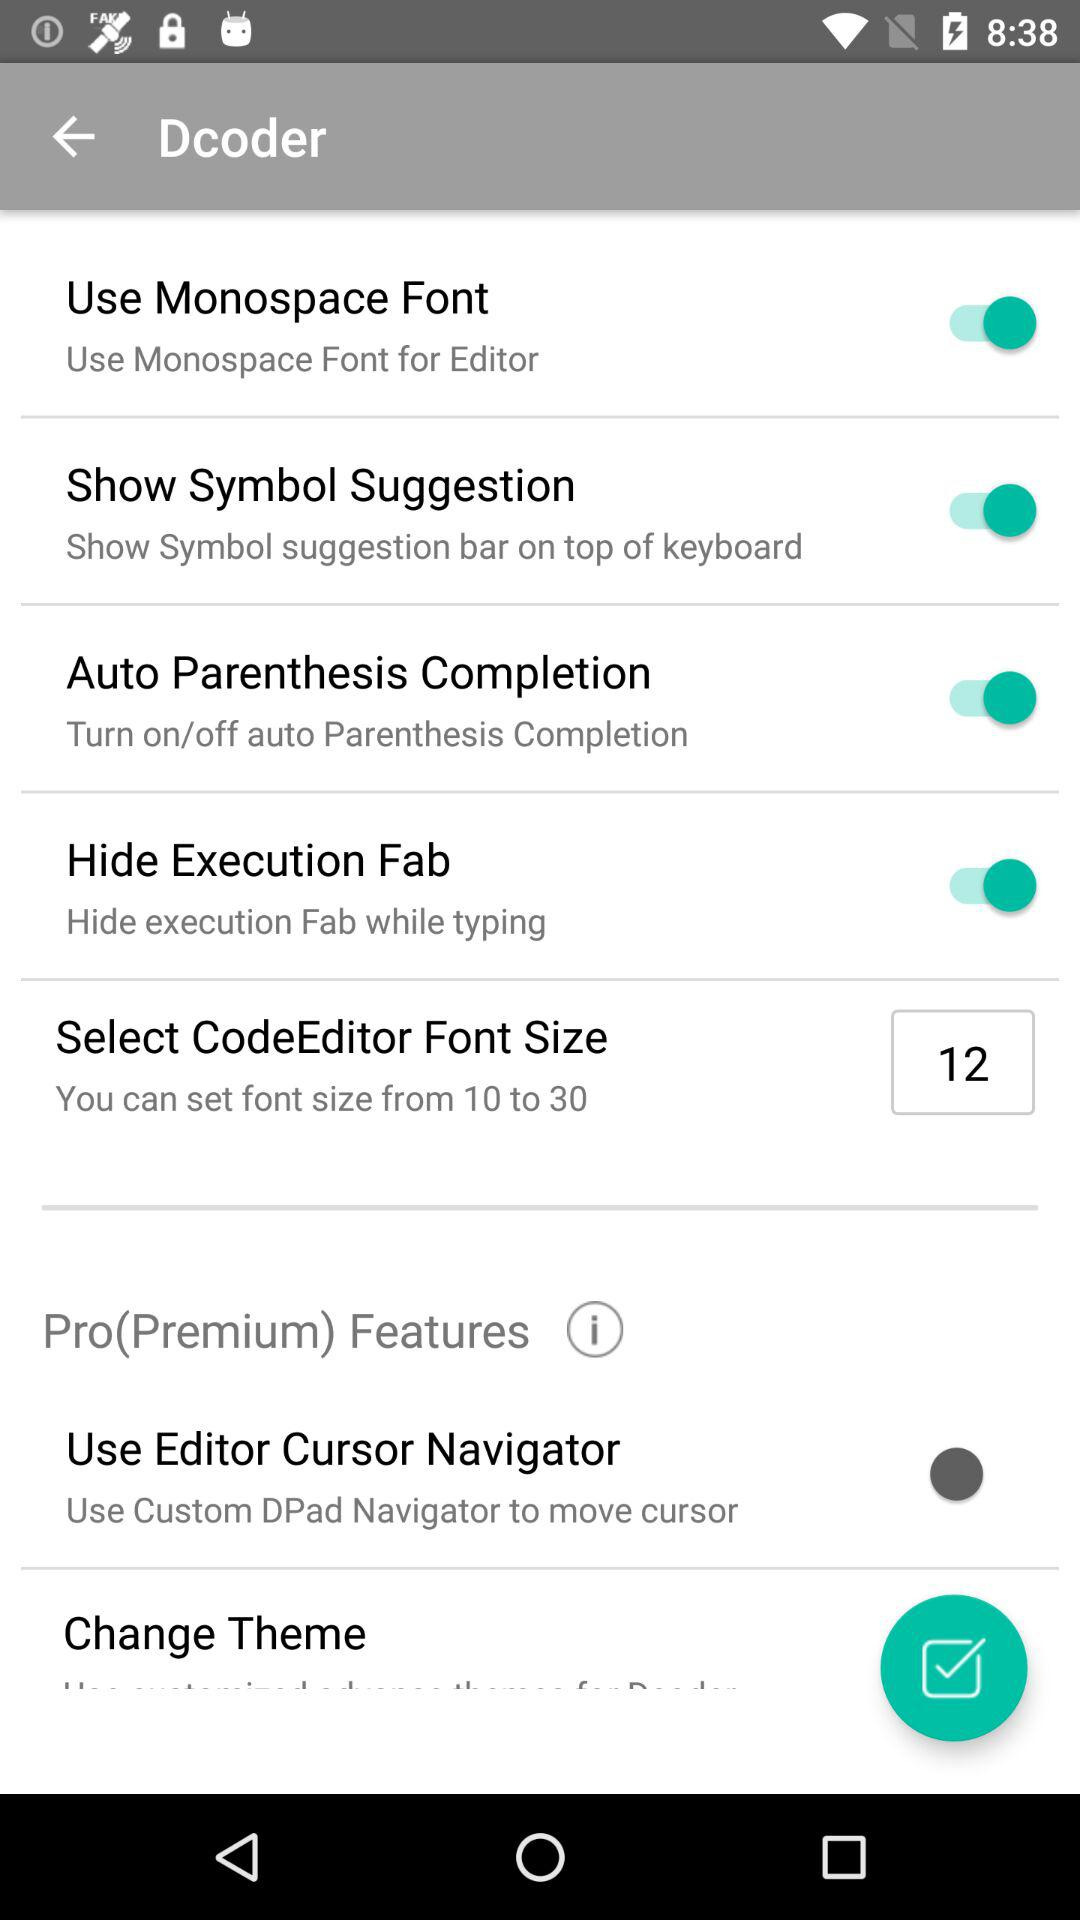What is the status of the "Use Monospace Font"? The status of the "Use Monospace Font" is "on". 